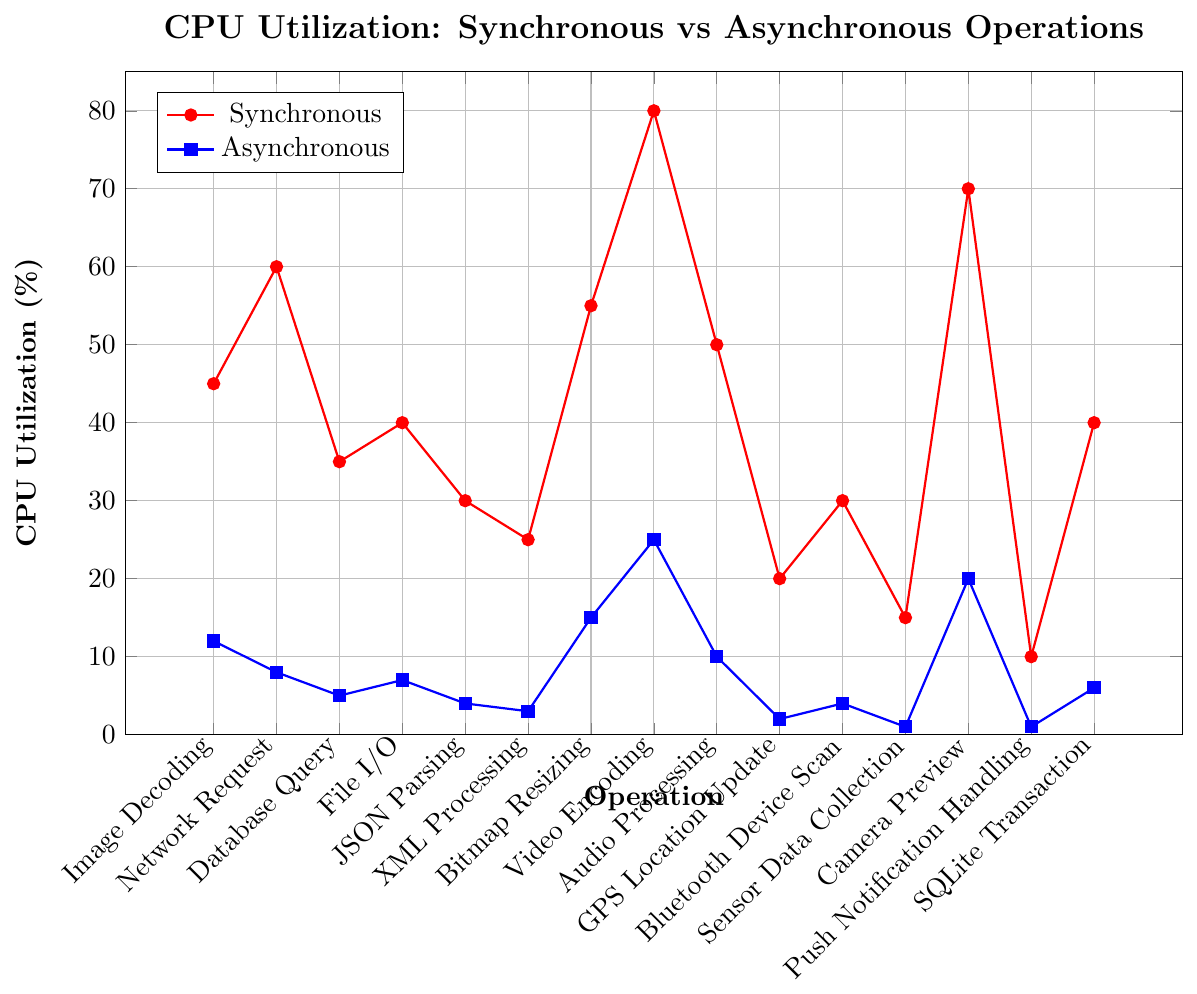What is the maximum CPU utilization for synchronous operations? By looking at the synchronous plot (red line), the highest point on the y-axis shows the CPU utilization. The maximum CPU utilization for Video Encoding is 80%.
Answer: 80% Which operation has the smallest difference in CPU utilization between synchronous and asynchronous? To find the smallest difference, subtract the asynchronous CPU utilization from the synchronous one for each operation. The smallest difference is for Camera Preview (70%-20%=50%, the highest next smallest difference is Image Decoding (45%-12%=33%)).
Answer: Camera Preview How much higher is the CPU utilization of synchronous Network Request compared to asynchronous Network Request? Subtract the asynchronous CPU utilization for Network Request from the synchronous one. 60% (synchronous) - 8% (asynchronous) = 52%.
Answer: 52% Which operations have less than 10% CPU utilization in asynchronous mode? Look at the blue plot (asynchronous) and find operations where the y-value is less than 10. Those operations are Image Decoding, Network Request, Database Query, File I/O, JSON Parsing, XML Processing, Audio Processing, GPS Location Update, Bluetooth Device Scan, Sensor Data Collection, Push Notification Handling, and SQLite Transaction.
Answer: 11 operations What is the average CPU utilization for synchronous operations across all activities? Add up the CPU utilizations for synchronous operations (45, 60, 35, 40, 30, 25, 55, 80, 50, 20, 30, 15, 70, 10, 40) and divide by the number of activities (15). The sum is 605. 605/15 = 40.33%
Answer: 40.33% Which operation shows the largest relative reduction in CPU utilization when moved from synchronous to asynchronous? Calculate the percentage reduction for each operation: (Synchronous - Asynchronous) / Synchronous * 100%. The largest reduction is for GPS Location Update: (20-2)/20*100% = 90%.
Answer: GPS Location Update Is there any operation where asynchronous CPU utilization is more than double that of synchronous? Double each of the asynchronous values and compare with the corresponding synchronous values. No operation has asynchronous CPU utilization more than double the synchronous.
Answer: No What is the average CPU utilization difference between synchronous and asynchronous modes? Subtract each asynchronous CPU value from the synchronous one and sum the differences, then divide by the number of operations. Sum of differences: (33 + 52 + 30 + 33 + 26 + 22 + 40 + 55 + 40 + 18 + 26 + 14 + 50 + 9 + 34) = 482. 482/15 = 32.13%.
Answer: 32.13% For operations with synchronous CPU utilization over 50%, what is the total CPU utilization in asynchronous mode? Filter the operations with synchronous CPU utilization over 50% (Network Request, Bitmap Resizing, Video Encoding, Camera Preview) and sum the corresponding asynchronous values: 8 + 15 + 25 + 20 = 68.
Answer: 68% Which operations have a synchronous CPU utilization that is less than 30%? Look at the red plot (synchronous) and identify the operations below 30%. These are JSON Parsing (30), XML Processing (25), GPS Location Update (20), Bluetooth Device Scan (30), Sensor Data Collection (15), Push Notification Handling (10). Note: JSON Parsing has exactly 30%.
Answer: 6 operations 